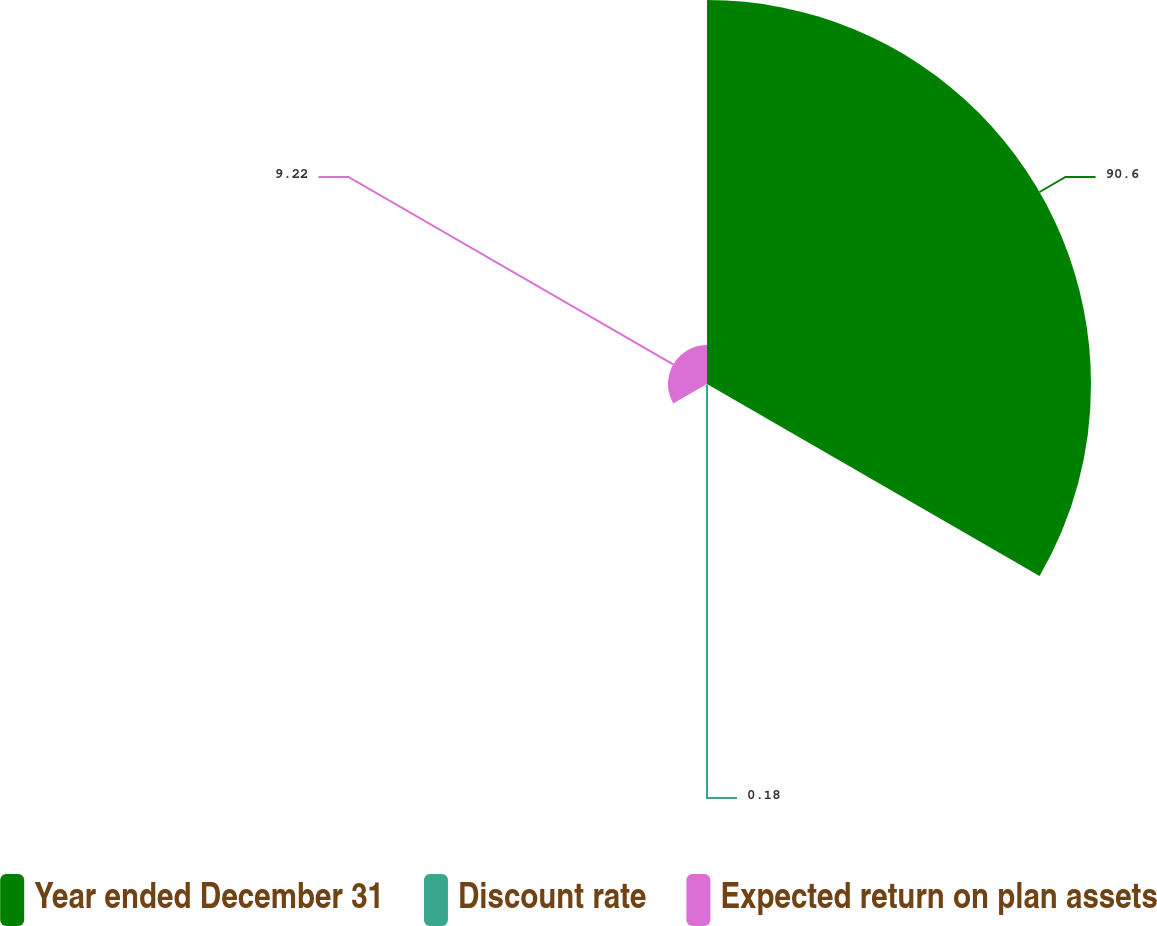Convert chart to OTSL. <chart><loc_0><loc_0><loc_500><loc_500><pie_chart><fcel>Year ended December 31<fcel>Discount rate<fcel>Expected return on plan assets<nl><fcel>90.6%<fcel>0.18%<fcel>9.22%<nl></chart> 